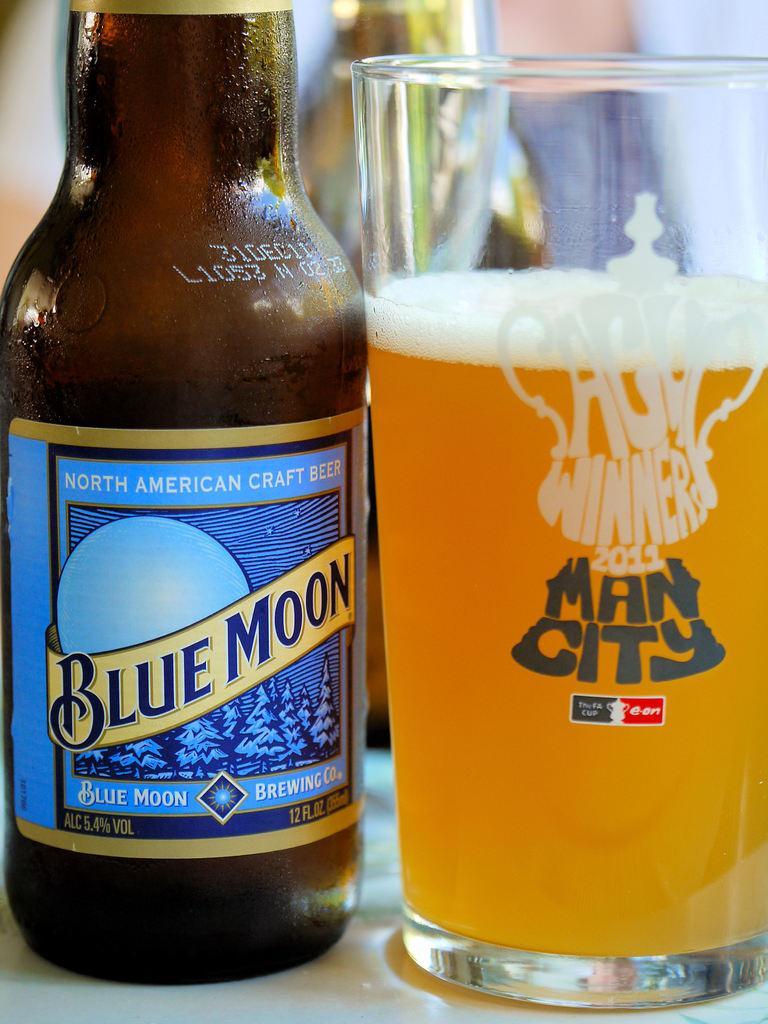Please provide a concise description of this image. There is a beer bottle and a glass full of beer placed on a table. This beer bottle has a label attached to it. 